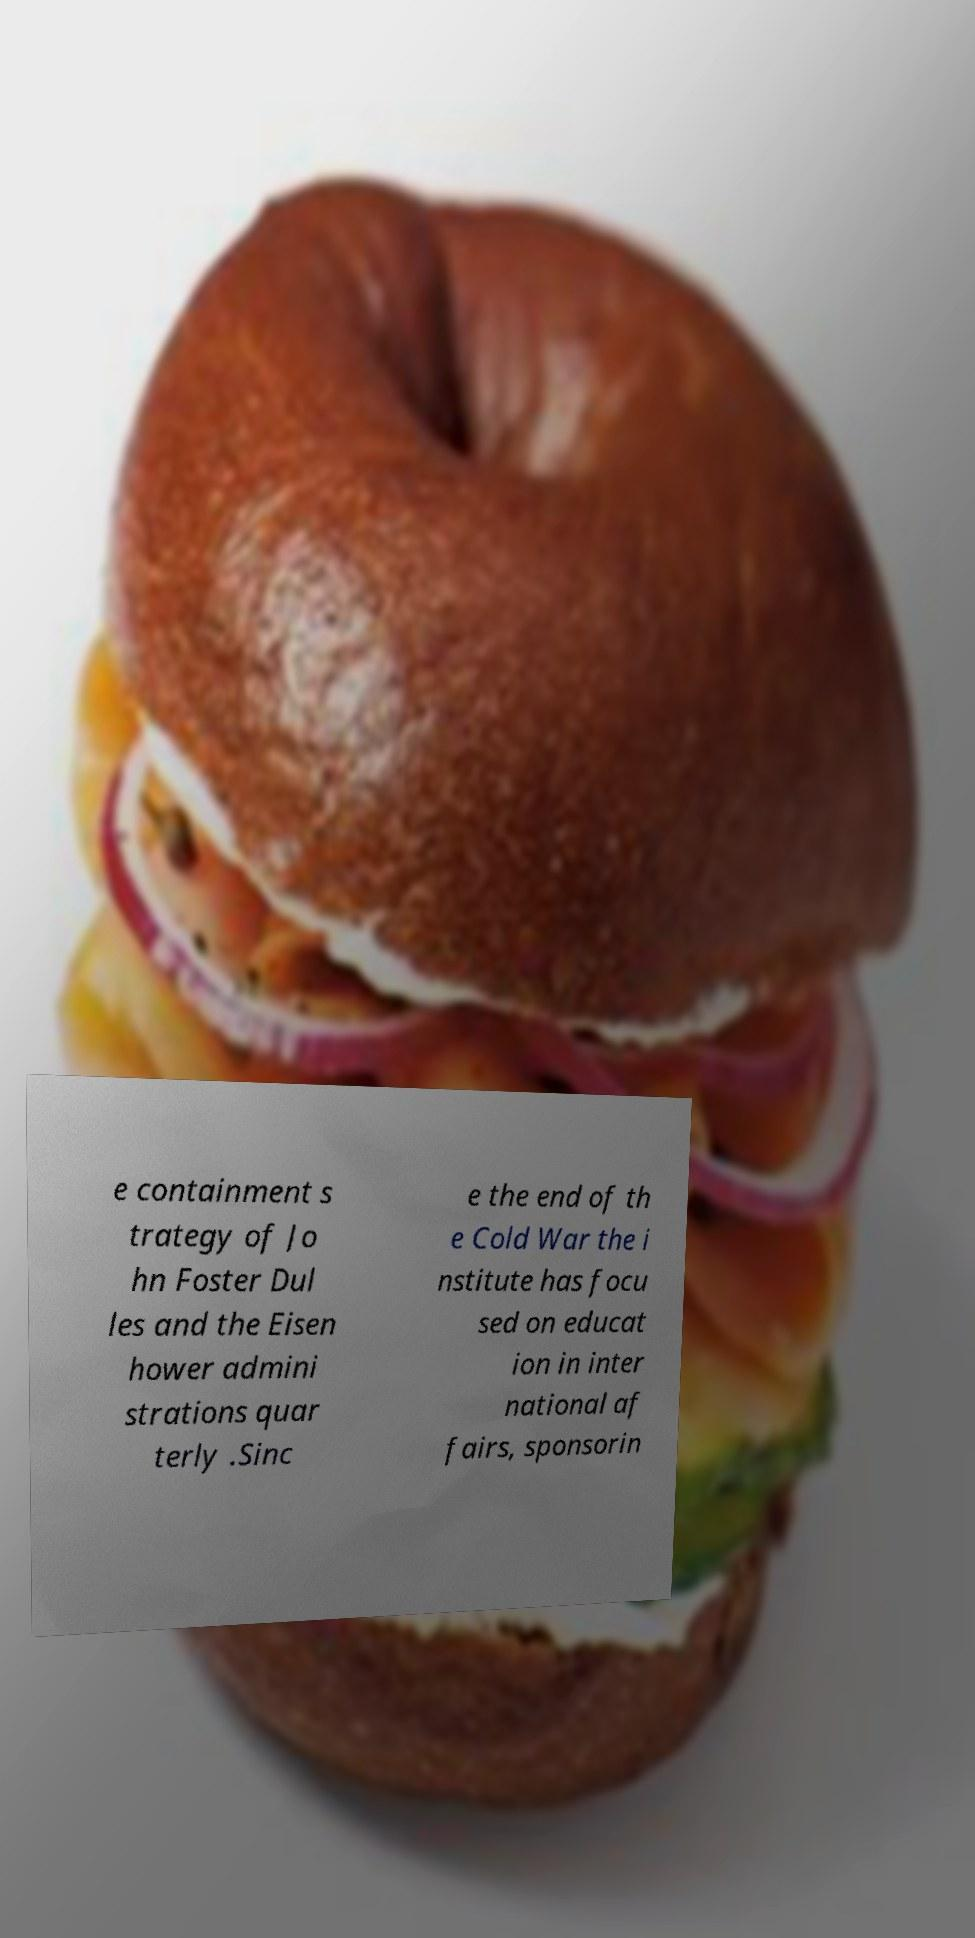Can you accurately transcribe the text from the provided image for me? e containment s trategy of Jo hn Foster Dul les and the Eisen hower admini strations quar terly .Sinc e the end of th e Cold War the i nstitute has focu sed on educat ion in inter national af fairs, sponsorin 